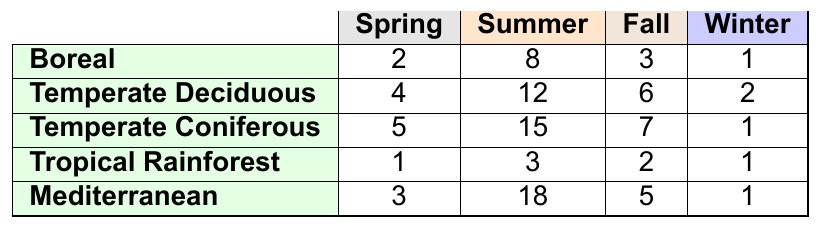What is the wildfire occurrence rate for the Temperate Deciduous forest in Summer? The table shows that for the Temperate Deciduous forest during Summer, the occurrence rate is 12.
Answer: 12 Which forest type has the highest wildfire occurrence rate in Fall? By looking at the Fall column, the Temperate Coniferous forest has the highest occurrence rate at 7.
Answer: Temperate Coniferous What is the total wildfire occurrence rate for Boreal forests across all seasons? Adding the rates for the Boreal forest: 2 (Spring) + 8 (Summer) + 3 (Fall) + 1 (Winter) = 14.
Answer: 14 Is the wildfire occurrence rate for Tropical Rainforest higher in Summer than in Winter? In Summer, the rate is 3, and in Winter, it is 1. Since 3 > 1, the statement is true.
Answer: Yes What is the average wildfire occurrence rate for Mediterranean forests? Adding the Mediterranean rates: 3 (Spring) + 18 (Summer) + 5 (Fall) + 1 (Winter) = 27. There are 4 seasons, so average = 27 / 4 = 6.75.
Answer: 6.75 Which forest type has the least wildfire occurrence rate in Winter? The table shows that both Tropical Rainforest and Mediterranean have the same occurrence rate of 1, which is the lowest.
Answer: Tropical Rainforest and Mediterranean Calculate the difference in wildfire occurrence rates between Summer and Fall for Temperate Coniferous forests. The rate in Summer is 15 and in Fall is 7. The difference is 15 - 7 = 8.
Answer: 8 Is the total wildfire occurrence rate across all seasons greater for Tropical Rainforest or Boreal forests? For Tropical Rainforest: 1 + 3 + 2 + 1 = 7; for Boreal: 2 + 8 + 3 + 1 = 14. Since 7 < 14, the Boreal forests have a higher total.
Answer: Boreal forests Which season shows the highest average wildfire occurrence rate across all forest types? Average rates for each season: Spring = (2 + 4 + 5 + 1 + 3)/5 = 3; Summer = (8 + 12 + 15 + 3 + 18)/5 = 11.2; Fall = (3 + 6 + 7 + 2 + 5)/5 = 4.6; Winter = (1 + 2 + 1 + 1 + 1)/5 = 1. The highest is Summer at 11.2.
Answer: Summer If the wildfire occurrence rates for all forest types in Winter are summed up, what is the total? The Winter rates are 1 (Boreal) + 2 (Temperate Deciduous) + 1 (Temperate Coniferous) + 1 (Tropical Rainforest) + 1 (Mediterranean) = 6.
Answer: 6 